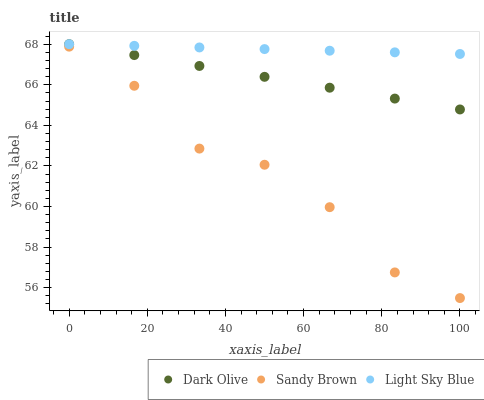Does Sandy Brown have the minimum area under the curve?
Answer yes or no. Yes. Does Light Sky Blue have the maximum area under the curve?
Answer yes or no. Yes. Does Light Sky Blue have the minimum area under the curve?
Answer yes or no. No. Does Sandy Brown have the maximum area under the curve?
Answer yes or no. No. Is Dark Olive the smoothest?
Answer yes or no. Yes. Is Sandy Brown the roughest?
Answer yes or no. Yes. Is Light Sky Blue the smoothest?
Answer yes or no. No. Is Light Sky Blue the roughest?
Answer yes or no. No. Does Sandy Brown have the lowest value?
Answer yes or no. Yes. Does Light Sky Blue have the lowest value?
Answer yes or no. No. Does Light Sky Blue have the highest value?
Answer yes or no. Yes. Does Sandy Brown have the highest value?
Answer yes or no. No. Is Sandy Brown less than Light Sky Blue?
Answer yes or no. Yes. Is Light Sky Blue greater than Sandy Brown?
Answer yes or no. Yes. Does Light Sky Blue intersect Dark Olive?
Answer yes or no. Yes. Is Light Sky Blue less than Dark Olive?
Answer yes or no. No. Is Light Sky Blue greater than Dark Olive?
Answer yes or no. No. Does Sandy Brown intersect Light Sky Blue?
Answer yes or no. No. 